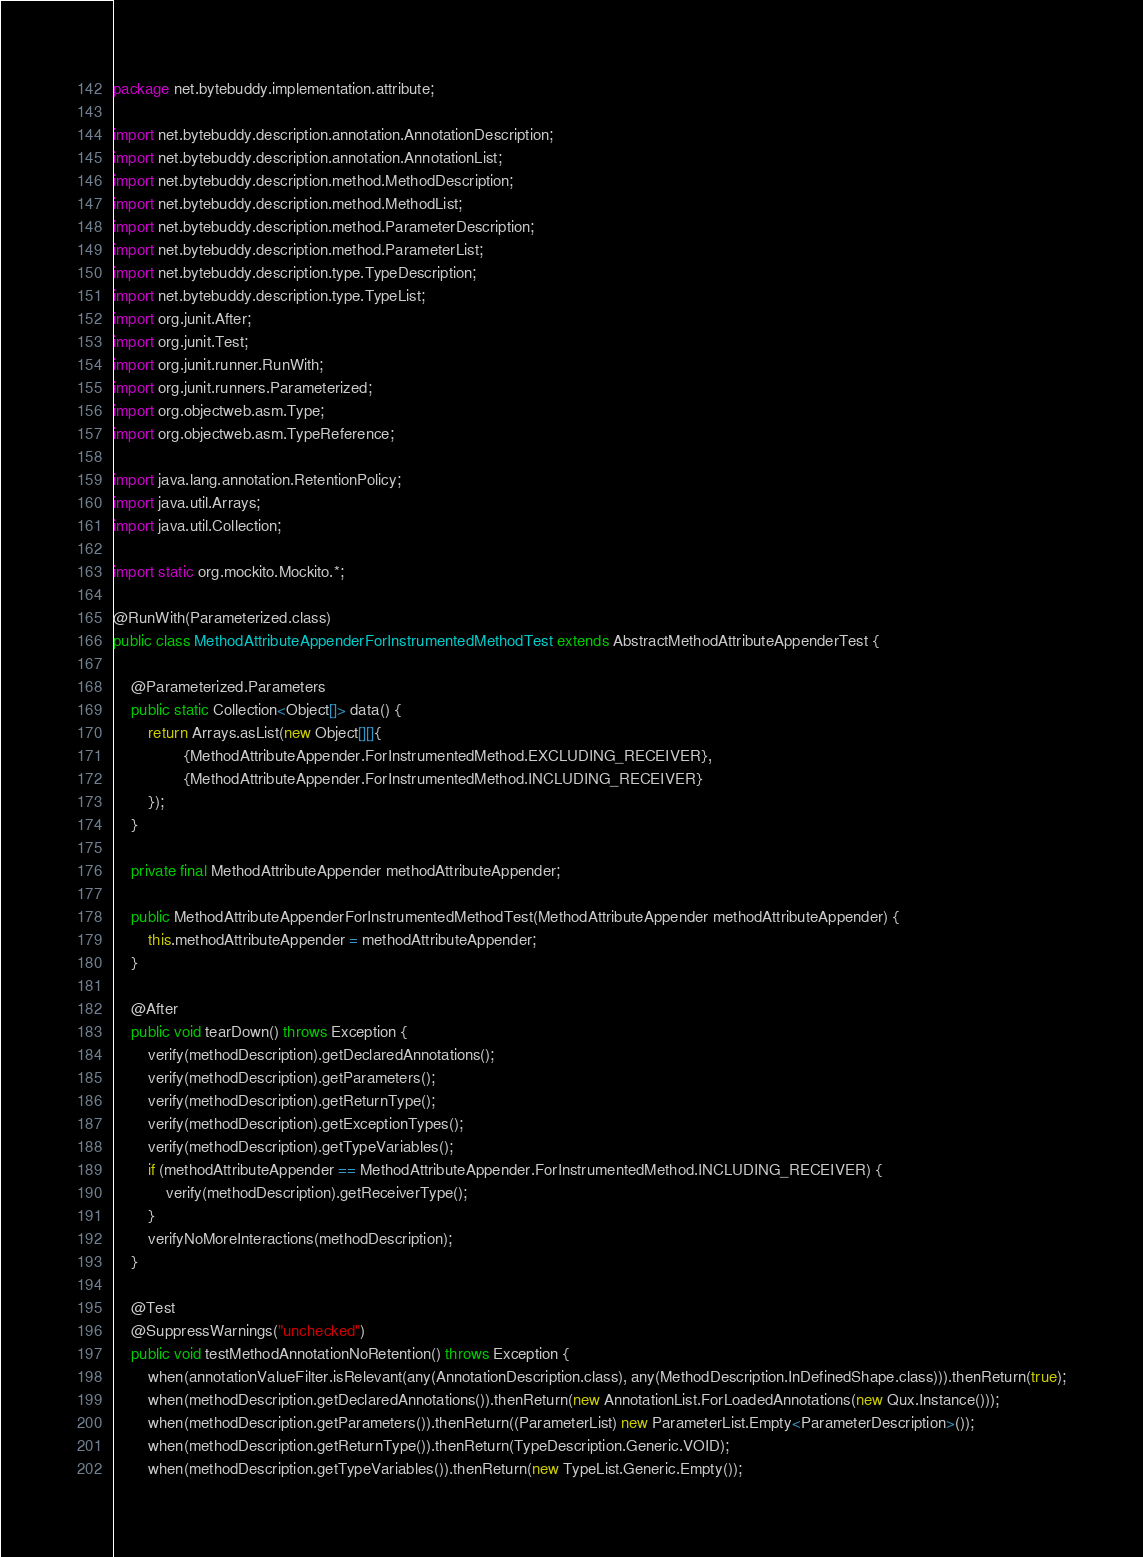<code> <loc_0><loc_0><loc_500><loc_500><_Java_>package net.bytebuddy.implementation.attribute;

import net.bytebuddy.description.annotation.AnnotationDescription;
import net.bytebuddy.description.annotation.AnnotationList;
import net.bytebuddy.description.method.MethodDescription;
import net.bytebuddy.description.method.MethodList;
import net.bytebuddy.description.method.ParameterDescription;
import net.bytebuddy.description.method.ParameterList;
import net.bytebuddy.description.type.TypeDescription;
import net.bytebuddy.description.type.TypeList;
import org.junit.After;
import org.junit.Test;
import org.junit.runner.RunWith;
import org.junit.runners.Parameterized;
import org.objectweb.asm.Type;
import org.objectweb.asm.TypeReference;

import java.lang.annotation.RetentionPolicy;
import java.util.Arrays;
import java.util.Collection;

import static org.mockito.Mockito.*;

@RunWith(Parameterized.class)
public class MethodAttributeAppenderForInstrumentedMethodTest extends AbstractMethodAttributeAppenderTest {

    @Parameterized.Parameters
    public static Collection<Object[]> data() {
        return Arrays.asList(new Object[][]{
                {MethodAttributeAppender.ForInstrumentedMethod.EXCLUDING_RECEIVER},
                {MethodAttributeAppender.ForInstrumentedMethod.INCLUDING_RECEIVER}
        });
    }

    private final MethodAttributeAppender methodAttributeAppender;

    public MethodAttributeAppenderForInstrumentedMethodTest(MethodAttributeAppender methodAttributeAppender) {
        this.methodAttributeAppender = methodAttributeAppender;
    }

    @After
    public void tearDown() throws Exception {
        verify(methodDescription).getDeclaredAnnotations();
        verify(methodDescription).getParameters();
        verify(methodDescription).getReturnType();
        verify(methodDescription).getExceptionTypes();
        verify(methodDescription).getTypeVariables();
        if (methodAttributeAppender == MethodAttributeAppender.ForInstrumentedMethod.INCLUDING_RECEIVER) {
            verify(methodDescription).getReceiverType();
        }
        verifyNoMoreInteractions(methodDescription);
    }

    @Test
    @SuppressWarnings("unchecked")
    public void testMethodAnnotationNoRetention() throws Exception {
        when(annotationValueFilter.isRelevant(any(AnnotationDescription.class), any(MethodDescription.InDefinedShape.class))).thenReturn(true);
        when(methodDescription.getDeclaredAnnotations()).thenReturn(new AnnotationList.ForLoadedAnnotations(new Qux.Instance()));
        when(methodDescription.getParameters()).thenReturn((ParameterList) new ParameterList.Empty<ParameterDescription>());
        when(methodDescription.getReturnType()).thenReturn(TypeDescription.Generic.VOID);
        when(methodDescription.getTypeVariables()).thenReturn(new TypeList.Generic.Empty());</code> 